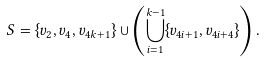<formula> <loc_0><loc_0><loc_500><loc_500>S = \{ v _ { 2 } , v _ { 4 } , v _ { 4 k + 1 } \} \cup \left ( \bigcup _ { i = 1 } ^ { k - 1 } \{ v _ { 4 i + 1 } , v _ { 4 i + 4 } \} \right ) .</formula> 